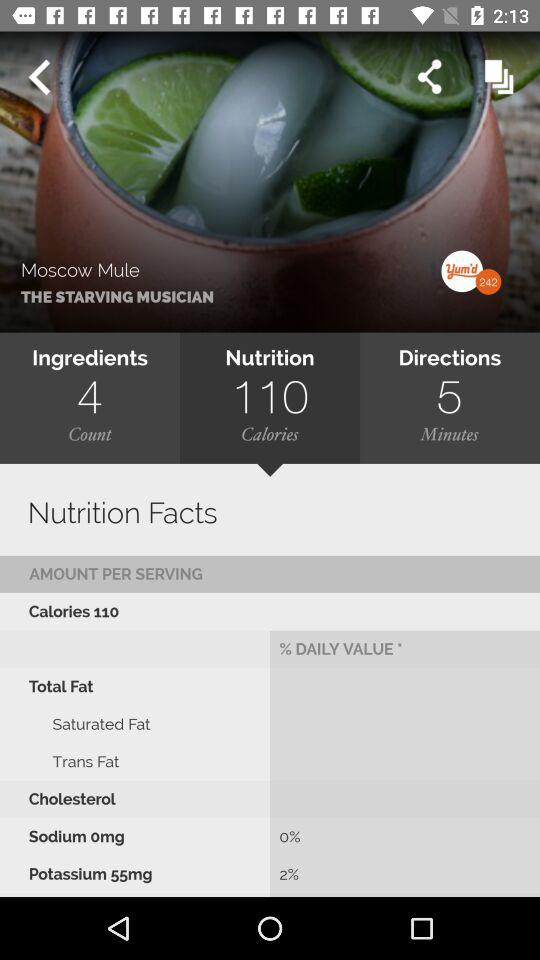What is the daily value of "Sodium 0mg" in percentage? The daily value of "Sodium 0mg" in percentage is 0. 